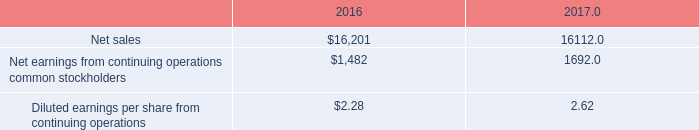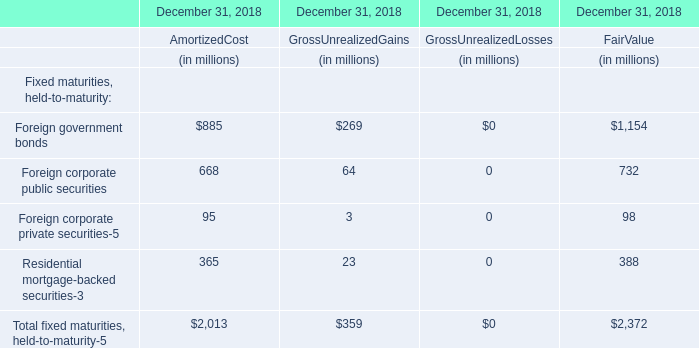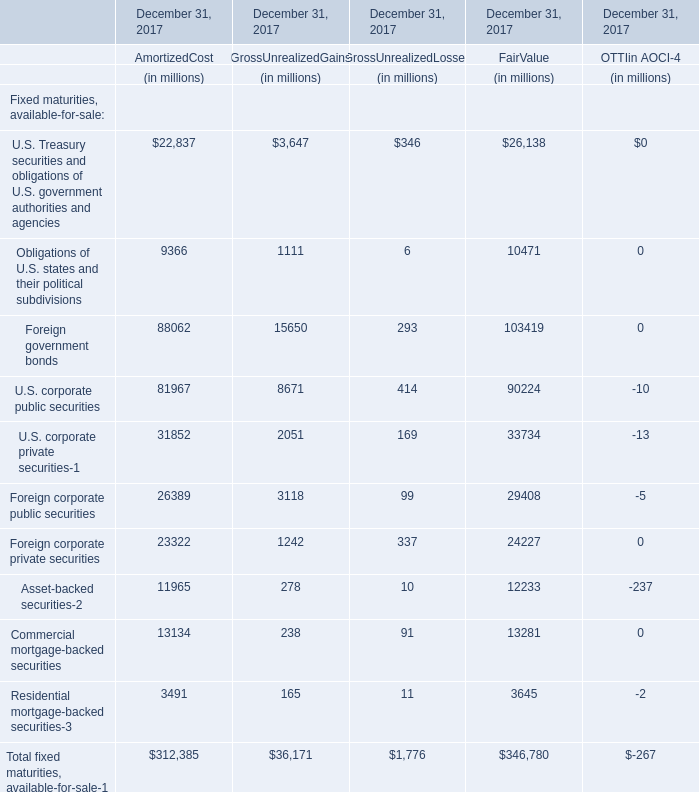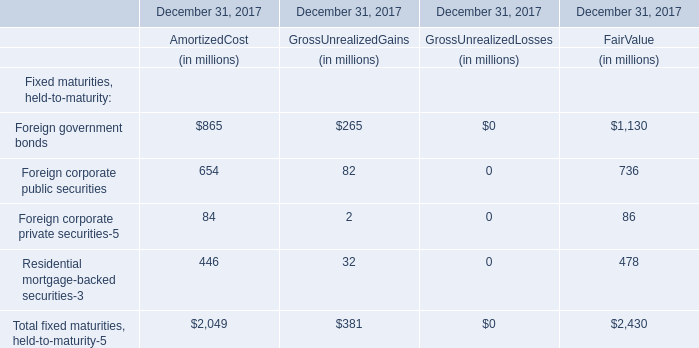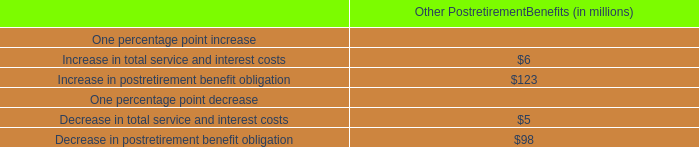what is the highest total amount of fair value? 
Answer: Foreign government bonds(1130). 